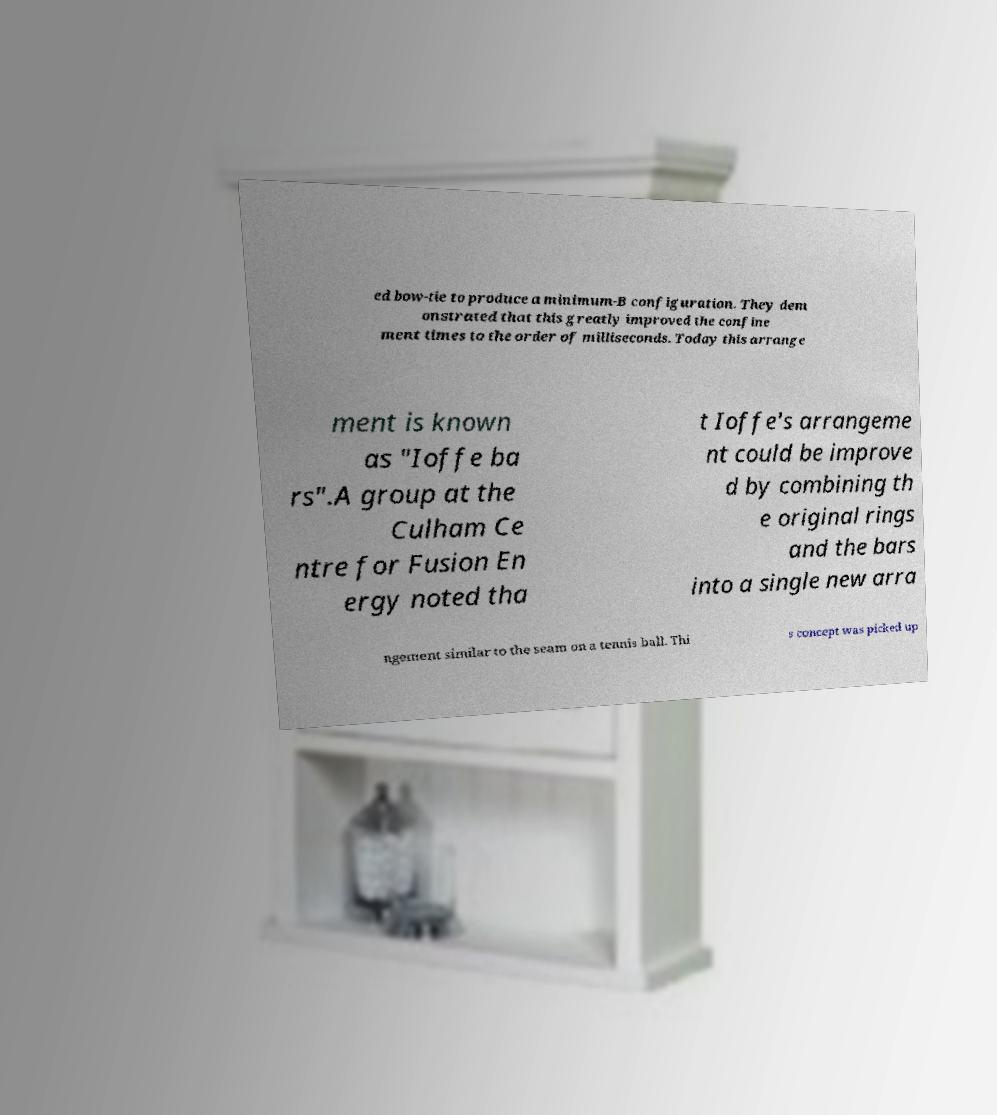For documentation purposes, I need the text within this image transcribed. Could you provide that? ed bow-tie to produce a minimum-B configuration. They dem onstrated that this greatly improved the confine ment times to the order of milliseconds. Today this arrange ment is known as "Ioffe ba rs".A group at the Culham Ce ntre for Fusion En ergy noted tha t Ioffe's arrangeme nt could be improve d by combining th e original rings and the bars into a single new arra ngement similar to the seam on a tennis ball. Thi s concept was picked up 